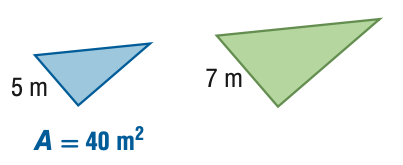Question: For the pair of similar figures, find the area of the green figure.
Choices:
A. 20.4
B. 28.6
C. 56.0
D. 78.4
Answer with the letter. Answer: D 